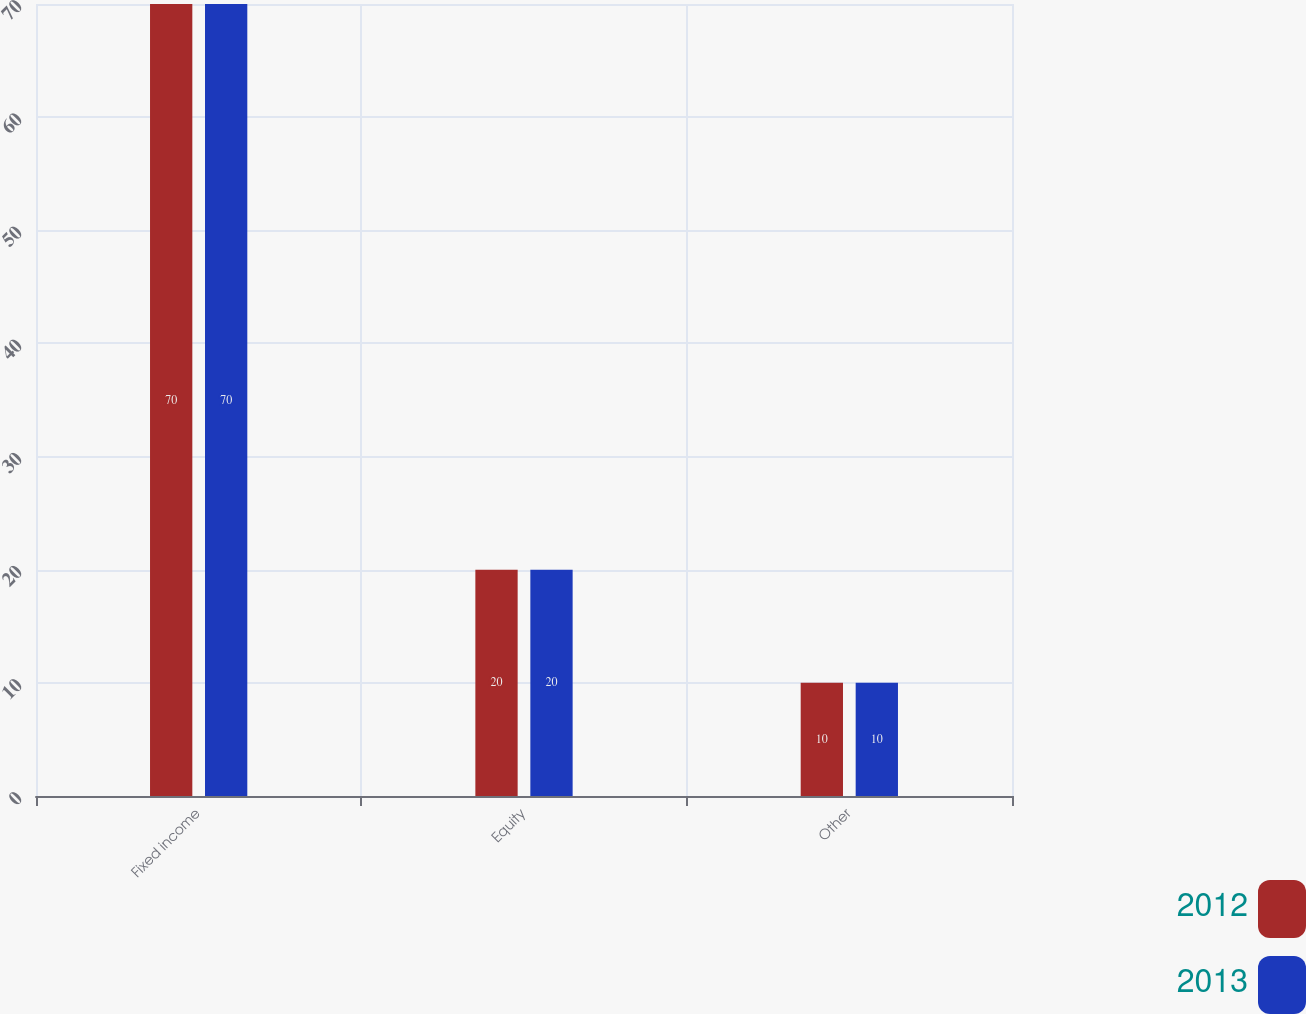Convert chart. <chart><loc_0><loc_0><loc_500><loc_500><stacked_bar_chart><ecel><fcel>Fixed income<fcel>Equity<fcel>Other<nl><fcel>2012<fcel>70<fcel>20<fcel>10<nl><fcel>2013<fcel>70<fcel>20<fcel>10<nl></chart> 